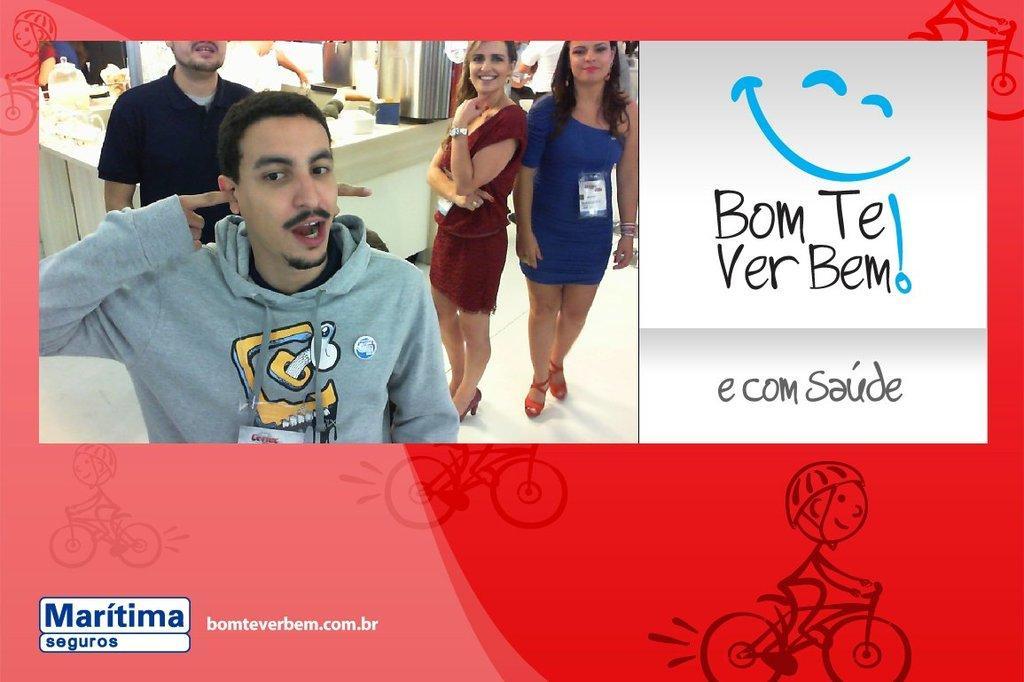Describe this image in one or two sentences. In this image there is a banner. There are pictures and text on the banner. In the top left there are pictures of four people standing on the floor. They are smiling. Behind them there is a table. To the right there is text on the image. At the bottom there are animated pictures of a person driving bicycle. 